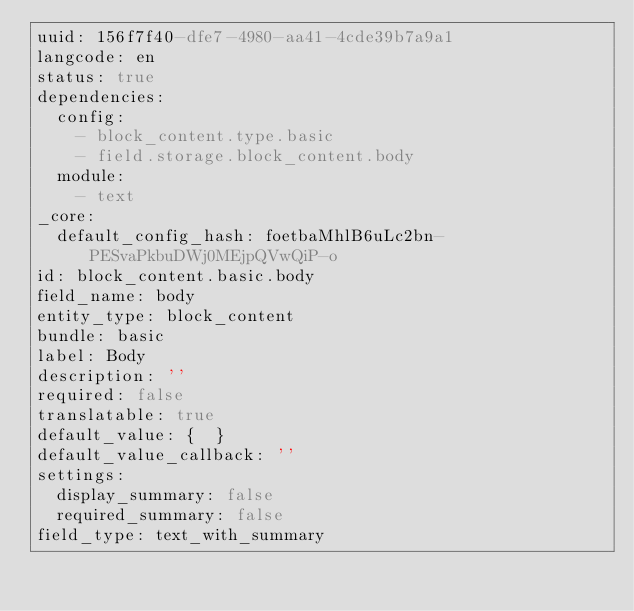<code> <loc_0><loc_0><loc_500><loc_500><_YAML_>uuid: 156f7f40-dfe7-4980-aa41-4cde39b7a9a1
langcode: en
status: true
dependencies:
  config:
    - block_content.type.basic
    - field.storage.block_content.body
  module:
    - text
_core:
  default_config_hash: foetbaMhlB6uLc2bn-PESvaPkbuDWj0MEjpQVwQiP-o
id: block_content.basic.body
field_name: body
entity_type: block_content
bundle: basic
label: Body
description: ''
required: false
translatable: true
default_value: {  }
default_value_callback: ''
settings:
  display_summary: false
  required_summary: false
field_type: text_with_summary
</code> 